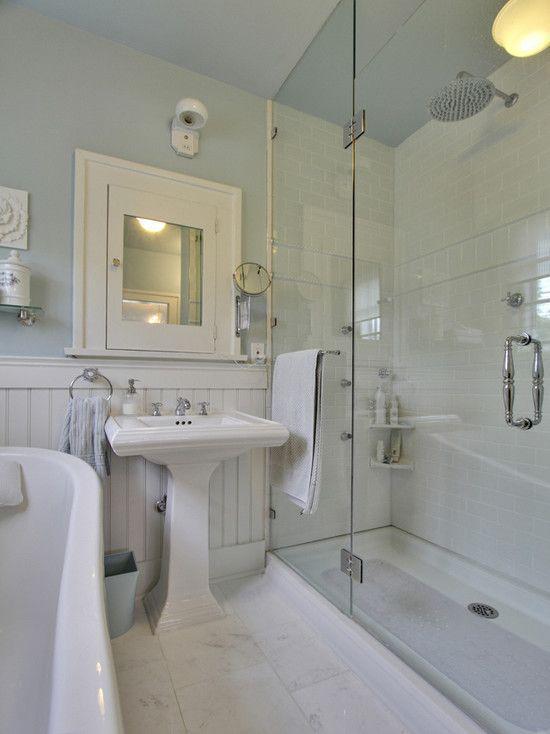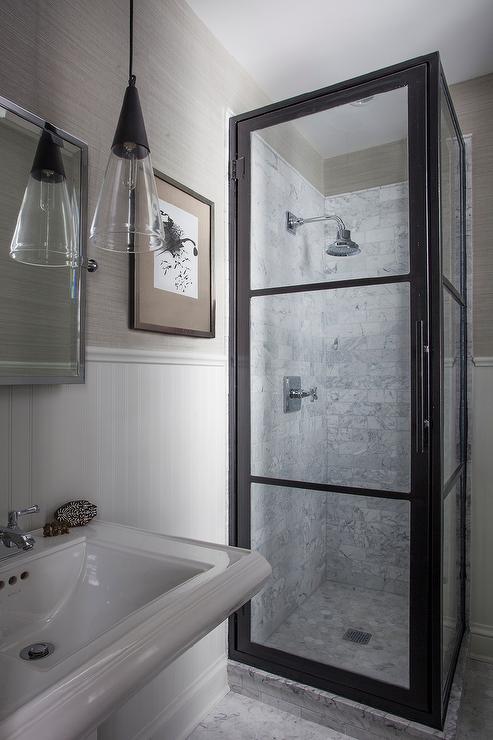The first image is the image on the left, the second image is the image on the right. Examine the images to the left and right. Is the description "There is a toilet in one image and a shower in the other." accurate? Answer yes or no. No. The first image is the image on the left, the second image is the image on the right. Analyze the images presented: Is the assertion "There are two sinks." valid? Answer yes or no. Yes. 